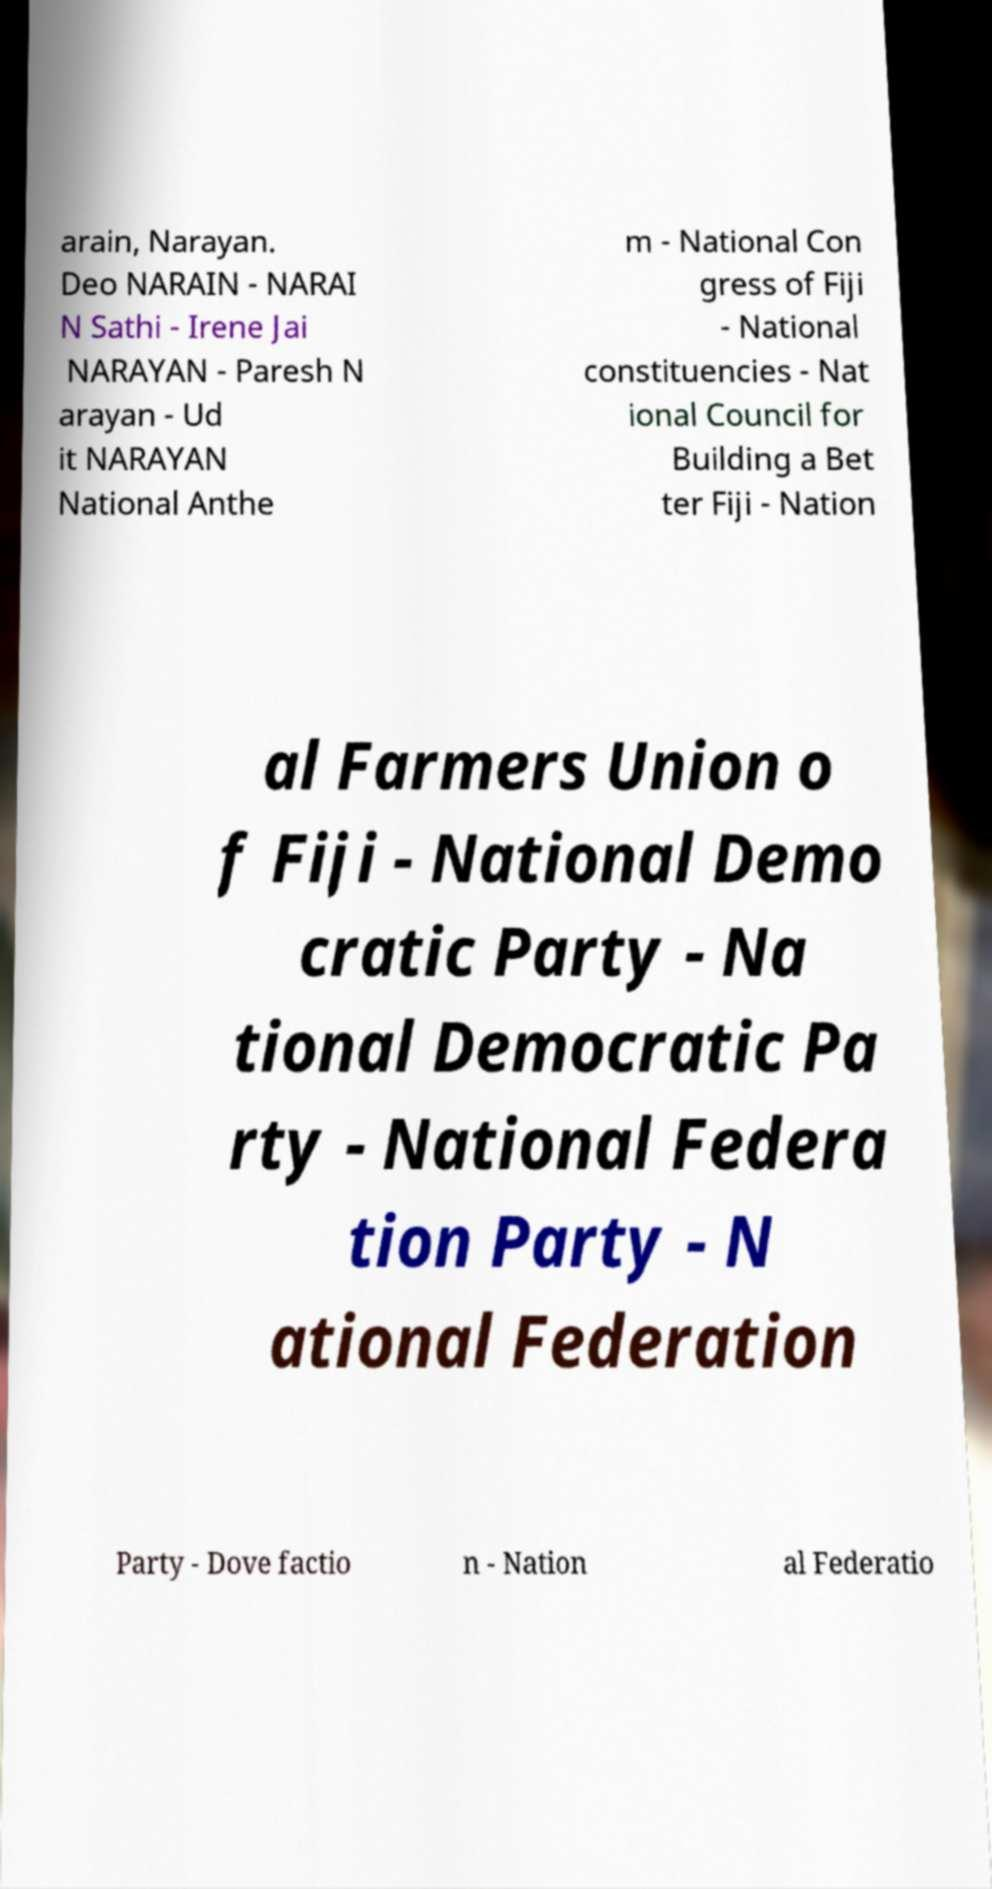Please read and relay the text visible in this image. What does it say? arain, Narayan. Deo NARAIN - NARAI N Sathi - Irene Jai NARAYAN - Paresh N arayan - Ud it NARAYAN National Anthe m - National Con gress of Fiji - National constituencies - Nat ional Council for Building a Bet ter Fiji - Nation al Farmers Union o f Fiji - National Demo cratic Party - Na tional Democratic Pa rty - National Federa tion Party - N ational Federation Party - Dove factio n - Nation al Federatio 